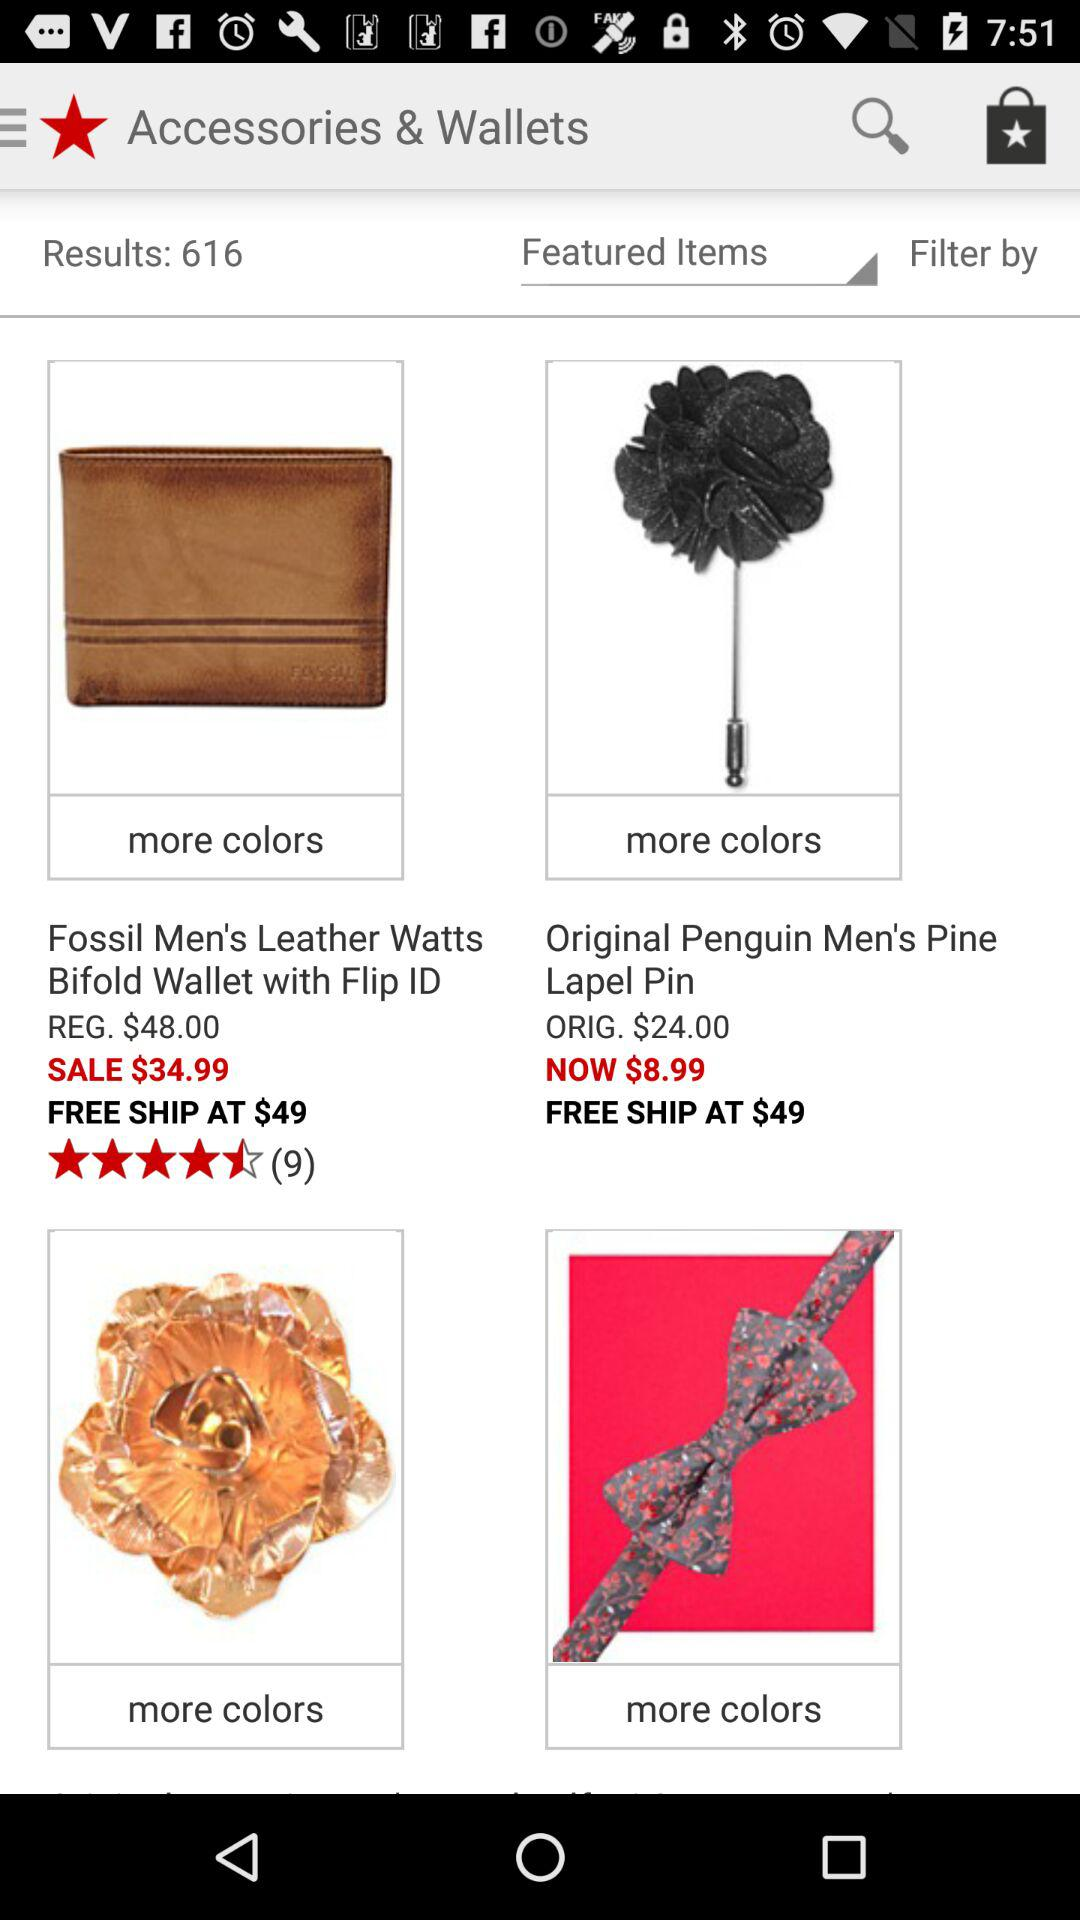What is the original price of the "Men's Pine Lapel Pin"? The original price is $24. 